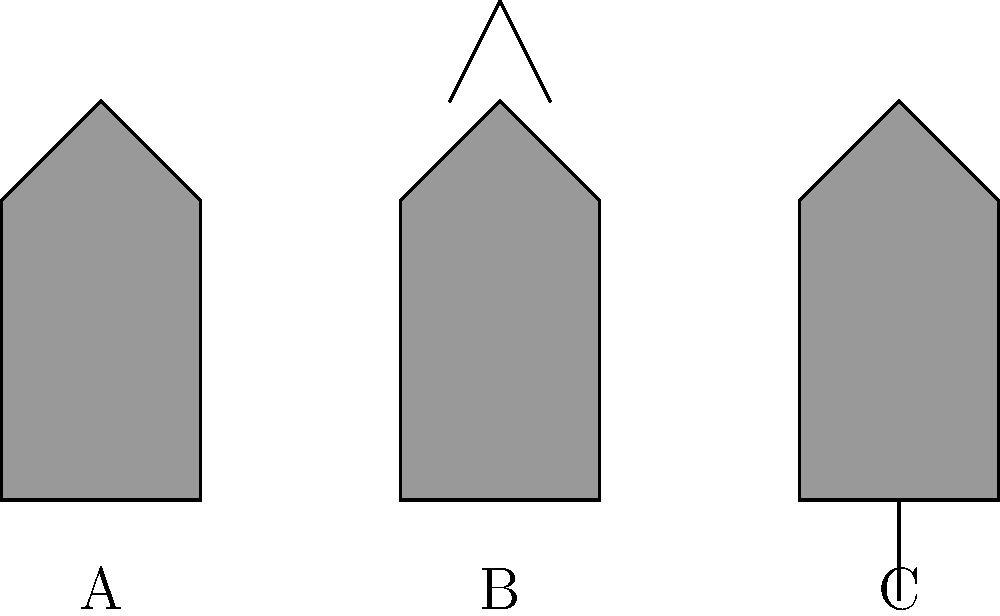As a children's book author specializing in puppet show stories, identify the types of puppets represented by the silhouettes A, B, and C in the image above. To identify the puppet types from their silhouettes, let's analyze each one:

1. Silhouette A:
   - Simple, rounded shape
   - No visible strings or rods
   - Resembles a hand with a hollow interior
   This is characteristic of a hand puppet, which is operated by inserting a hand inside.

2. Silhouette B:
   - Human-like shape
   - Visible strings attached to the top
   - Strings imply control from above
   This represents a marionette, which is controlled by strings from above.

3. Silhouette C:
   - Flat, two-dimensional appearance
   - Visible rod or stick at the bottom
   - Simple outline suitable for casting shadows
   This depicts a shadow puppet, typically used behind a screen with light projection.

By recognizing these distinct features, we can accurately identify each puppet type, which is crucial for writing stories tailored to specific puppet show performances.
Answer: A: Hand puppet, B: Marionette, C: Shadow puppet 